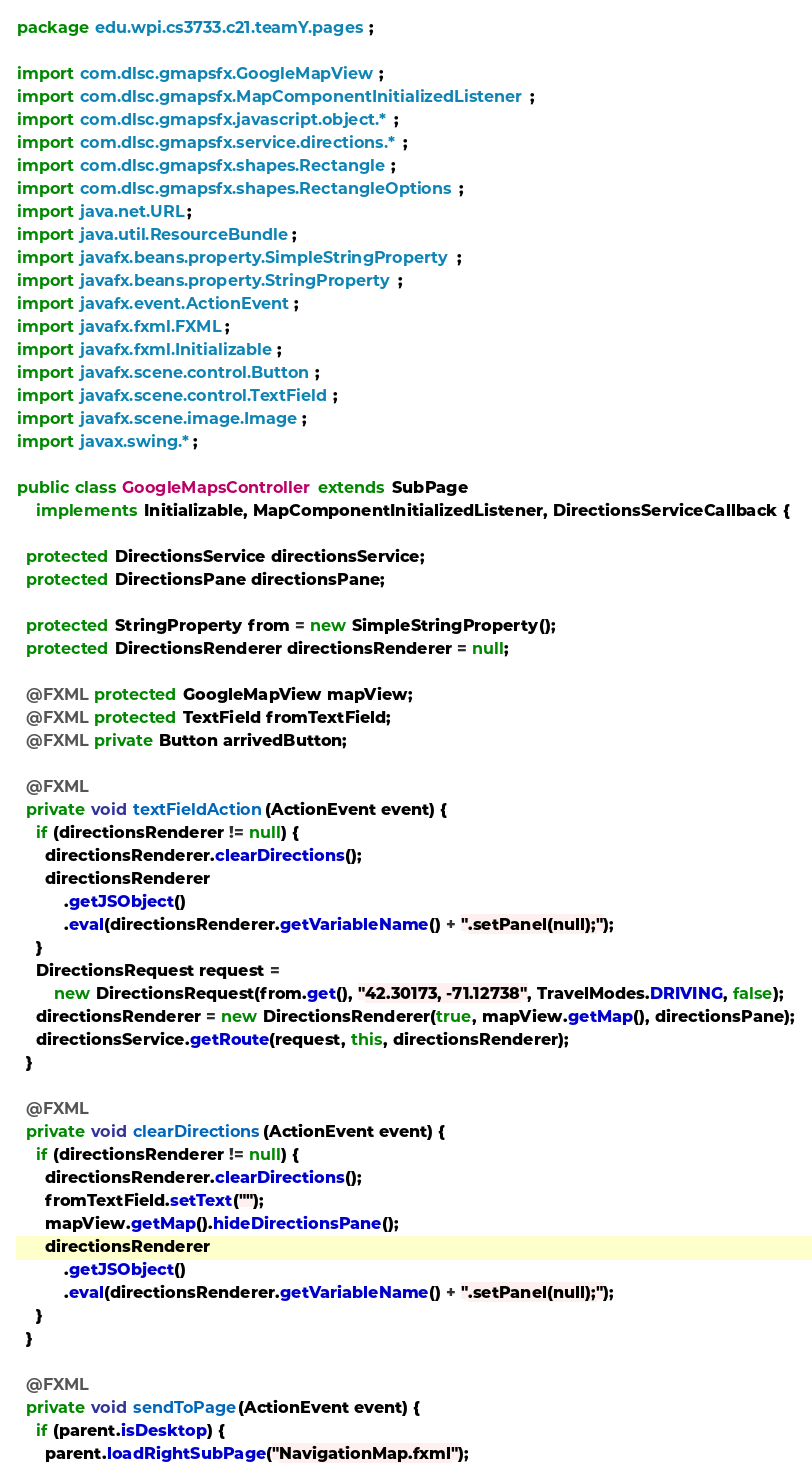Convert code to text. <code><loc_0><loc_0><loc_500><loc_500><_Java_>package edu.wpi.cs3733.c21.teamY.pages;

import com.dlsc.gmapsfx.GoogleMapView;
import com.dlsc.gmapsfx.MapComponentInitializedListener;
import com.dlsc.gmapsfx.javascript.object.*;
import com.dlsc.gmapsfx.service.directions.*;
import com.dlsc.gmapsfx.shapes.Rectangle;
import com.dlsc.gmapsfx.shapes.RectangleOptions;
import java.net.URL;
import java.util.ResourceBundle;
import javafx.beans.property.SimpleStringProperty;
import javafx.beans.property.StringProperty;
import javafx.event.ActionEvent;
import javafx.fxml.FXML;
import javafx.fxml.Initializable;
import javafx.scene.control.Button;
import javafx.scene.control.TextField;
import javafx.scene.image.Image;
import javax.swing.*;

public class GoogleMapsController extends SubPage
    implements Initializable, MapComponentInitializedListener, DirectionsServiceCallback {

  protected DirectionsService directionsService;
  protected DirectionsPane directionsPane;

  protected StringProperty from = new SimpleStringProperty();
  protected DirectionsRenderer directionsRenderer = null;

  @FXML protected GoogleMapView mapView;
  @FXML protected TextField fromTextField;
  @FXML private Button arrivedButton;

  @FXML
  private void textFieldAction(ActionEvent event) {
    if (directionsRenderer != null) {
      directionsRenderer.clearDirections();
      directionsRenderer
          .getJSObject()
          .eval(directionsRenderer.getVariableName() + ".setPanel(null);");
    }
    DirectionsRequest request =
        new DirectionsRequest(from.get(), "42.30173, -71.12738", TravelModes.DRIVING, false);
    directionsRenderer = new DirectionsRenderer(true, mapView.getMap(), directionsPane);
    directionsService.getRoute(request, this, directionsRenderer);
  }

  @FXML
  private void clearDirections(ActionEvent event) {
    if (directionsRenderer != null) {
      directionsRenderer.clearDirections();
      fromTextField.setText("");
      mapView.getMap().hideDirectionsPane();
      directionsRenderer
          .getJSObject()
          .eval(directionsRenderer.getVariableName() + ".setPanel(null);");
    }
  }

  @FXML
  private void sendToPage(ActionEvent event) {
    if (parent.isDesktop) {
      parent.loadRightSubPage("NavigationMap.fxml");</code> 